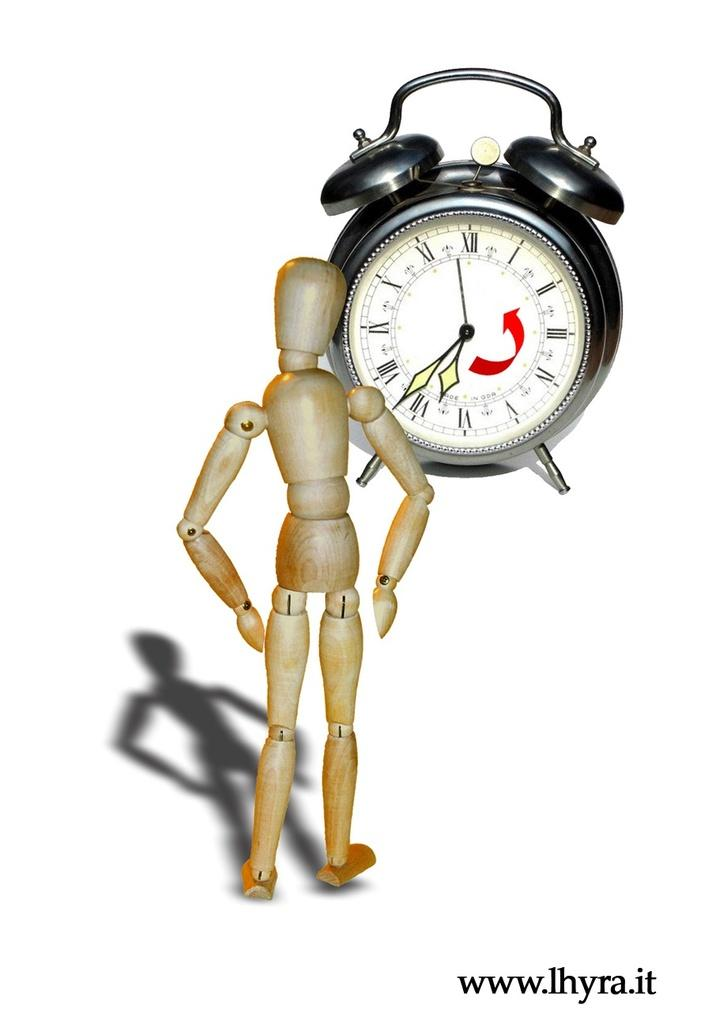<image>
Provide a brief description of the given image. The time on the alarm clock is 6:37. 